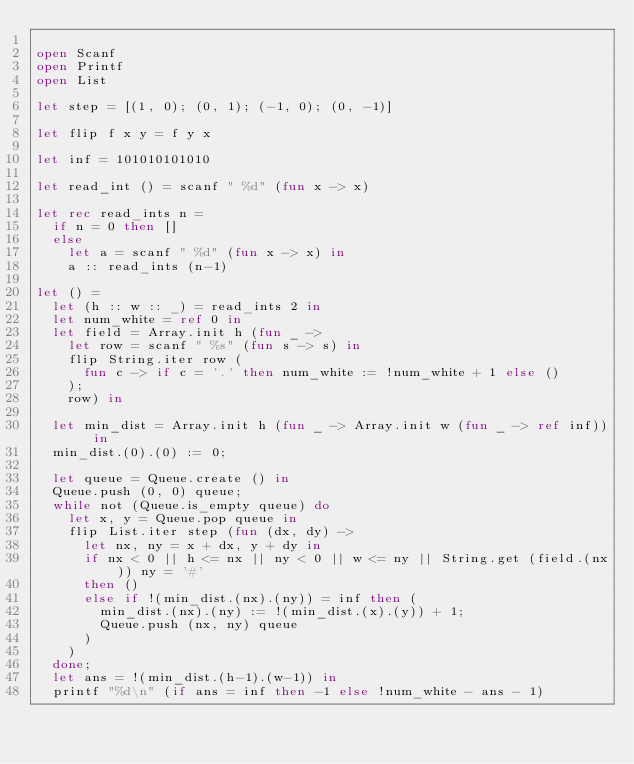Convert code to text. <code><loc_0><loc_0><loc_500><loc_500><_OCaml_>
open Scanf
open Printf
open List

let step = [(1, 0); (0, 1); (-1, 0); (0, -1)]

let flip f x y = f y x

let inf = 101010101010

let read_int () = scanf " %d" (fun x -> x)

let rec read_ints n =
  if n = 0 then []
  else
    let a = scanf " %d" (fun x -> x) in
    a :: read_ints (n-1)

let () =
  let (h :: w :: _) = read_ints 2 in
  let num_white = ref 0 in
  let field = Array.init h (fun _ ->
    let row = scanf " %s" (fun s -> s) in
    flip String.iter row (
      fun c -> if c = '.' then num_white := !num_white + 1 else ()
    );
    row) in

  let min_dist = Array.init h (fun _ -> Array.init w (fun _ -> ref inf)) in
  min_dist.(0).(0) := 0;

  let queue = Queue.create () in
  Queue.push (0, 0) queue;
  while not (Queue.is_empty queue) do
    let x, y = Queue.pop queue in
    flip List.iter step (fun (dx, dy) ->
      let nx, ny = x + dx, y + dy in
      if nx < 0 || h <= nx || ny < 0 || w <= ny || String.get (field.(nx)) ny = '#'
      then ()
      else if !(min_dist.(nx).(ny)) = inf then (
        min_dist.(nx).(ny) := !(min_dist.(x).(y)) + 1;
        Queue.push (nx, ny) queue
      )
    )
  done;
  let ans = !(min_dist.(h-1).(w-1)) in
  printf "%d\n" (if ans = inf then -1 else !num_white - ans - 1)

</code> 